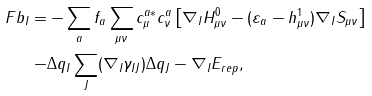Convert formula to latex. <formula><loc_0><loc_0><loc_500><loc_500>\ F b _ { I } = & - \sum _ { a } f _ { a } \sum _ { \mu \nu } c _ { \mu } ^ { a * } c _ { \nu } ^ { a } \left [ \nabla _ { I } H ^ { 0 } _ { \mu \nu } - ( \varepsilon _ { a } - h ^ { 1 } _ { \mu \nu } ) \nabla _ { I } S _ { \mu \nu } \right ] \\ - & \Delta q _ { I } \sum _ { J } ( \nabla _ { I } \gamma _ { I J } ) \Delta q _ { J } - \nabla _ { I } E _ { r e p } ,</formula> 